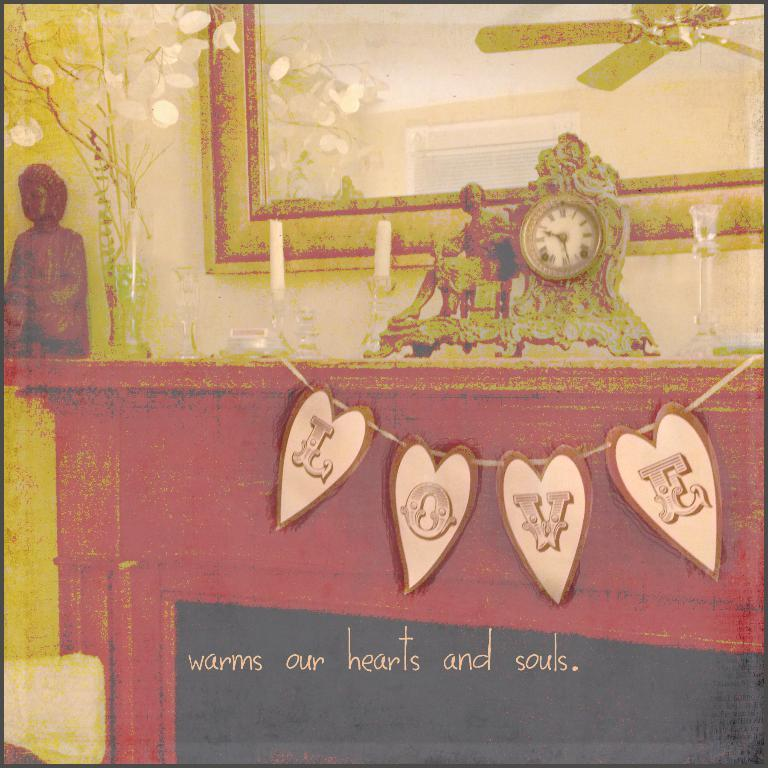<image>
Relay a brief, clear account of the picture shown. Poster that says "Warm our hearts and souls". 